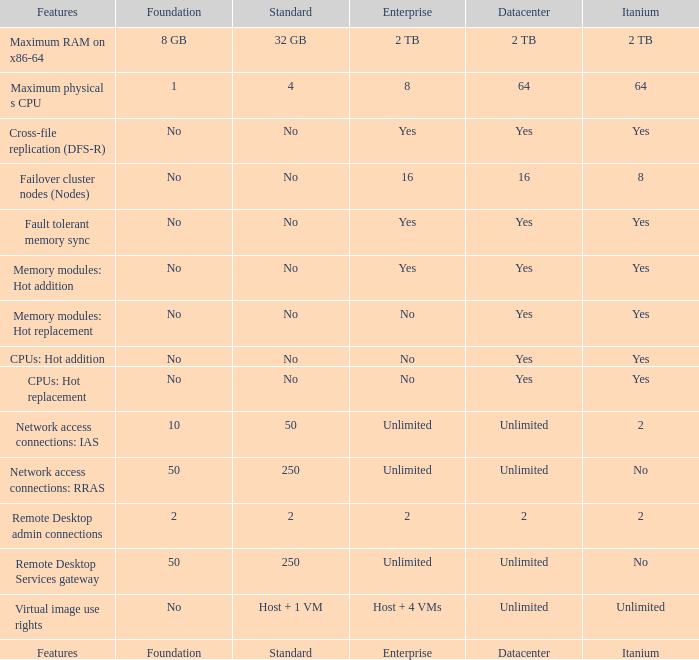What is the Datacenter for the Fault Tolerant Memory Sync Feature that has Yes for Itanium and No for Standard? Yes. 